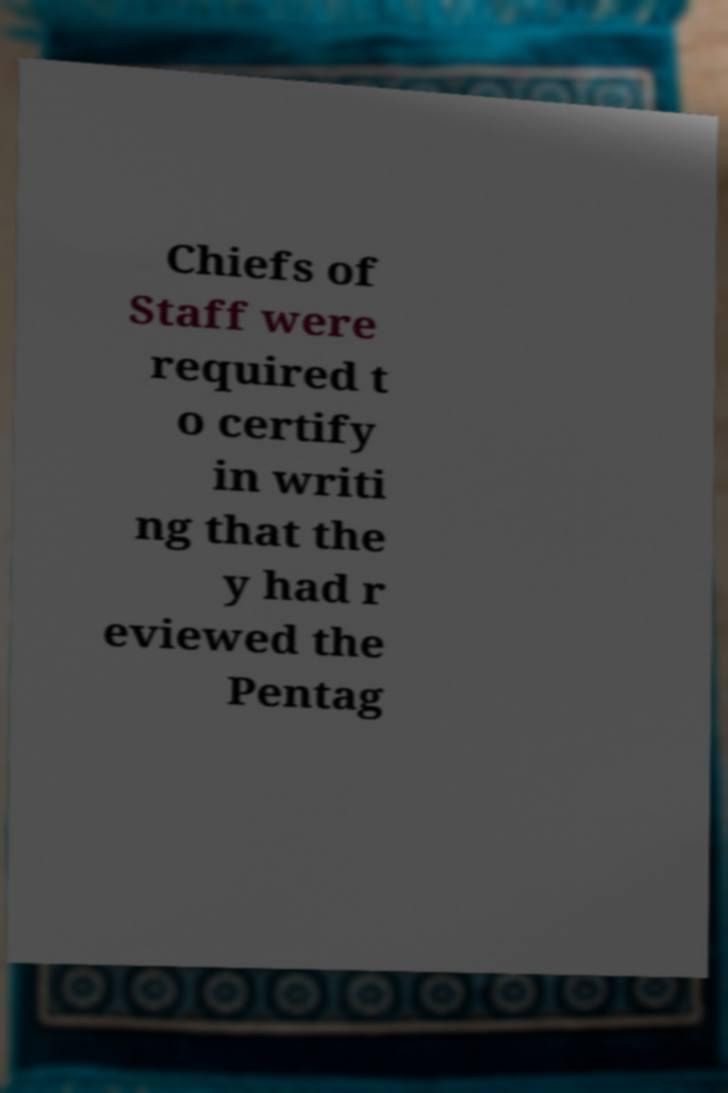For documentation purposes, I need the text within this image transcribed. Could you provide that? Chiefs of Staff were required t o certify in writi ng that the y had r eviewed the Pentag 